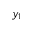Convert formula to latex. <formula><loc_0><loc_0><loc_500><loc_500>y _ { 1 }</formula> 